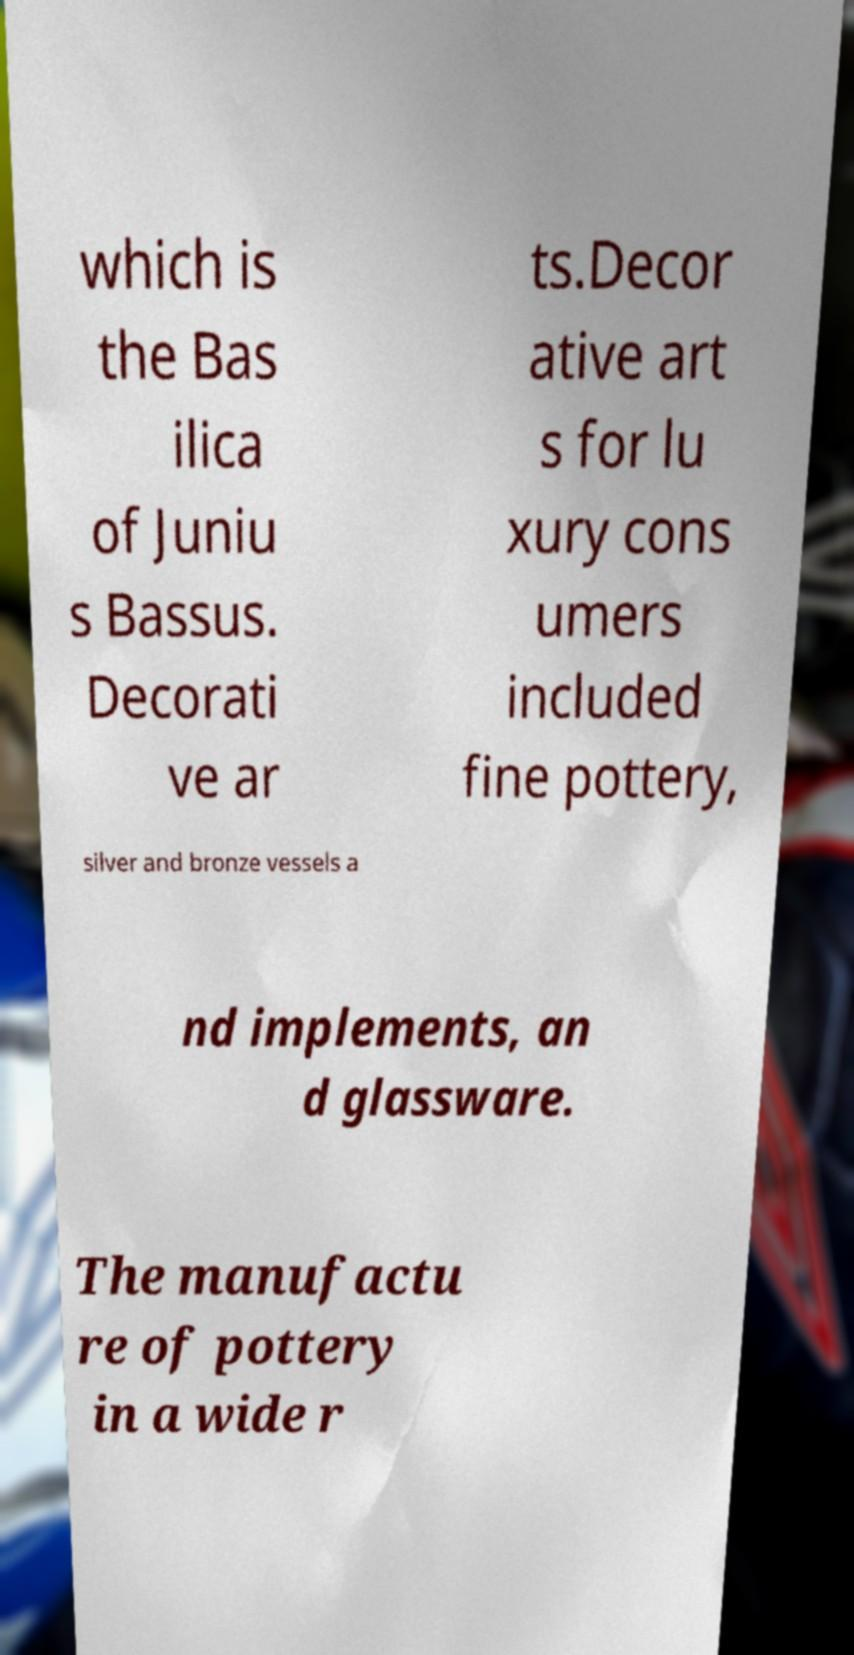Can you accurately transcribe the text from the provided image for me? which is the Bas ilica of Juniu s Bassus. Decorati ve ar ts.Decor ative art s for lu xury cons umers included fine pottery, silver and bronze vessels a nd implements, an d glassware. The manufactu re of pottery in a wide r 